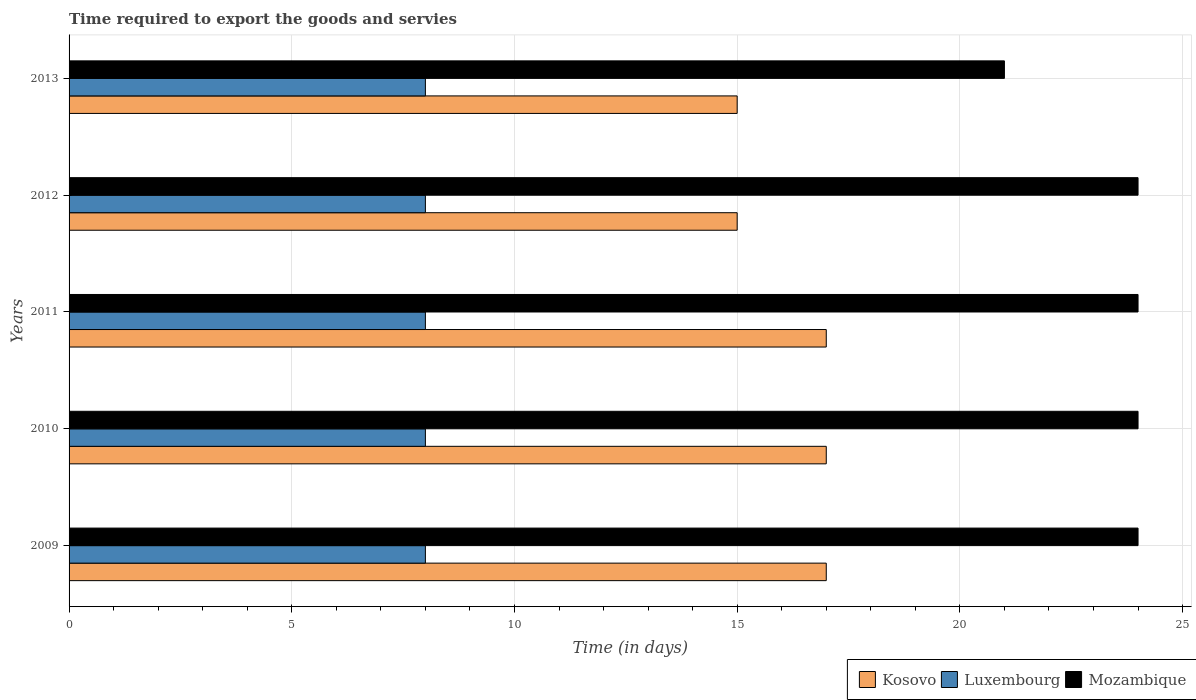How many different coloured bars are there?
Offer a very short reply. 3. How many groups of bars are there?
Give a very brief answer. 5. Are the number of bars per tick equal to the number of legend labels?
Give a very brief answer. Yes. Are the number of bars on each tick of the Y-axis equal?
Offer a very short reply. Yes. How many bars are there on the 4th tick from the bottom?
Give a very brief answer. 3. What is the label of the 5th group of bars from the top?
Offer a terse response. 2009. Across all years, what is the maximum number of days required to export the goods and services in Luxembourg?
Provide a short and direct response. 8. In which year was the number of days required to export the goods and services in Mozambique maximum?
Your answer should be compact. 2009. What is the total number of days required to export the goods and services in Mozambique in the graph?
Offer a terse response. 117. What is the difference between the number of days required to export the goods and services in Kosovo in 2011 and that in 2012?
Provide a short and direct response. 2. What is the difference between the number of days required to export the goods and services in Kosovo in 2011 and the number of days required to export the goods and services in Luxembourg in 2013?
Make the answer very short. 9. What is the average number of days required to export the goods and services in Mozambique per year?
Ensure brevity in your answer.  23.4. In how many years, is the number of days required to export the goods and services in Kosovo greater than 13 days?
Your answer should be very brief. 5. What is the ratio of the number of days required to export the goods and services in Luxembourg in 2009 to that in 2011?
Ensure brevity in your answer.  1. Is the number of days required to export the goods and services in Mozambique in 2012 less than that in 2013?
Give a very brief answer. No. In how many years, is the number of days required to export the goods and services in Kosovo greater than the average number of days required to export the goods and services in Kosovo taken over all years?
Your answer should be very brief. 3. What does the 1st bar from the top in 2010 represents?
Your response must be concise. Mozambique. What does the 3rd bar from the bottom in 2011 represents?
Your answer should be very brief. Mozambique. Is it the case that in every year, the sum of the number of days required to export the goods and services in Kosovo and number of days required to export the goods and services in Luxembourg is greater than the number of days required to export the goods and services in Mozambique?
Keep it short and to the point. No. How many bars are there?
Your response must be concise. 15. Are all the bars in the graph horizontal?
Your answer should be very brief. Yes. What is the difference between two consecutive major ticks on the X-axis?
Your answer should be very brief. 5. Does the graph contain any zero values?
Offer a very short reply. No. Where does the legend appear in the graph?
Your response must be concise. Bottom right. How many legend labels are there?
Give a very brief answer. 3. What is the title of the graph?
Give a very brief answer. Time required to export the goods and servies. Does "Poland" appear as one of the legend labels in the graph?
Keep it short and to the point. No. What is the label or title of the X-axis?
Keep it short and to the point. Time (in days). What is the label or title of the Y-axis?
Keep it short and to the point. Years. What is the Time (in days) of Kosovo in 2009?
Offer a very short reply. 17. What is the Time (in days) of Luxembourg in 2009?
Your answer should be compact. 8. What is the Time (in days) of Kosovo in 2010?
Provide a succinct answer. 17. What is the Time (in days) of Luxembourg in 2010?
Give a very brief answer. 8. What is the Time (in days) in Mozambique in 2010?
Your response must be concise. 24. What is the Time (in days) of Kosovo in 2011?
Offer a terse response. 17. What is the Time (in days) in Kosovo in 2012?
Your answer should be very brief. 15. What is the Time (in days) in Luxembourg in 2012?
Your response must be concise. 8. What is the Time (in days) in Mozambique in 2012?
Provide a succinct answer. 24. What is the Time (in days) of Mozambique in 2013?
Offer a terse response. 21. Across all years, what is the minimum Time (in days) of Kosovo?
Your answer should be very brief. 15. Across all years, what is the minimum Time (in days) in Luxembourg?
Your answer should be compact. 8. What is the total Time (in days) in Mozambique in the graph?
Provide a succinct answer. 117. What is the difference between the Time (in days) in Luxembourg in 2009 and that in 2010?
Offer a very short reply. 0. What is the difference between the Time (in days) in Mozambique in 2009 and that in 2010?
Provide a short and direct response. 0. What is the difference between the Time (in days) of Kosovo in 2009 and that in 2011?
Your response must be concise. 0. What is the difference between the Time (in days) in Mozambique in 2009 and that in 2011?
Provide a succinct answer. 0. What is the difference between the Time (in days) of Luxembourg in 2009 and that in 2012?
Make the answer very short. 0. What is the difference between the Time (in days) of Luxembourg in 2009 and that in 2013?
Give a very brief answer. 0. What is the difference between the Time (in days) of Luxembourg in 2010 and that in 2011?
Your answer should be compact. 0. What is the difference between the Time (in days) of Mozambique in 2010 and that in 2011?
Provide a short and direct response. 0. What is the difference between the Time (in days) of Mozambique in 2010 and that in 2012?
Offer a very short reply. 0. What is the difference between the Time (in days) in Kosovo in 2010 and that in 2013?
Your answer should be compact. 2. What is the difference between the Time (in days) of Kosovo in 2011 and that in 2012?
Offer a terse response. 2. What is the difference between the Time (in days) of Luxembourg in 2011 and that in 2013?
Your answer should be compact. 0. What is the difference between the Time (in days) of Luxembourg in 2012 and that in 2013?
Your answer should be very brief. 0. What is the difference between the Time (in days) of Mozambique in 2012 and that in 2013?
Provide a succinct answer. 3. What is the difference between the Time (in days) in Luxembourg in 2009 and the Time (in days) in Mozambique in 2010?
Keep it short and to the point. -16. What is the difference between the Time (in days) in Kosovo in 2009 and the Time (in days) in Luxembourg in 2011?
Offer a terse response. 9. What is the difference between the Time (in days) of Kosovo in 2009 and the Time (in days) of Luxembourg in 2012?
Offer a very short reply. 9. What is the difference between the Time (in days) in Luxembourg in 2009 and the Time (in days) in Mozambique in 2012?
Keep it short and to the point. -16. What is the difference between the Time (in days) of Kosovo in 2009 and the Time (in days) of Mozambique in 2013?
Provide a succinct answer. -4. What is the difference between the Time (in days) in Kosovo in 2010 and the Time (in days) in Mozambique in 2011?
Your answer should be compact. -7. What is the difference between the Time (in days) of Luxembourg in 2010 and the Time (in days) of Mozambique in 2011?
Your answer should be very brief. -16. What is the difference between the Time (in days) of Kosovo in 2010 and the Time (in days) of Luxembourg in 2012?
Make the answer very short. 9. What is the difference between the Time (in days) of Kosovo in 2010 and the Time (in days) of Mozambique in 2012?
Provide a short and direct response. -7. What is the difference between the Time (in days) of Kosovo in 2010 and the Time (in days) of Mozambique in 2013?
Your response must be concise. -4. What is the difference between the Time (in days) in Luxembourg in 2010 and the Time (in days) in Mozambique in 2013?
Give a very brief answer. -13. What is the difference between the Time (in days) of Kosovo in 2011 and the Time (in days) of Mozambique in 2012?
Your answer should be very brief. -7. What is the difference between the Time (in days) of Luxembourg in 2011 and the Time (in days) of Mozambique in 2013?
Provide a succinct answer. -13. What is the difference between the Time (in days) in Kosovo in 2012 and the Time (in days) in Mozambique in 2013?
Provide a succinct answer. -6. What is the average Time (in days) of Mozambique per year?
Your answer should be compact. 23.4. In the year 2009, what is the difference between the Time (in days) in Kosovo and Time (in days) in Mozambique?
Keep it short and to the point. -7. In the year 2010, what is the difference between the Time (in days) of Kosovo and Time (in days) of Mozambique?
Offer a terse response. -7. In the year 2010, what is the difference between the Time (in days) in Luxembourg and Time (in days) in Mozambique?
Keep it short and to the point. -16. In the year 2011, what is the difference between the Time (in days) in Kosovo and Time (in days) in Mozambique?
Provide a succinct answer. -7. In the year 2011, what is the difference between the Time (in days) of Luxembourg and Time (in days) of Mozambique?
Offer a terse response. -16. In the year 2012, what is the difference between the Time (in days) of Kosovo and Time (in days) of Luxembourg?
Give a very brief answer. 7. In the year 2013, what is the difference between the Time (in days) in Kosovo and Time (in days) in Mozambique?
Provide a short and direct response. -6. In the year 2013, what is the difference between the Time (in days) of Luxembourg and Time (in days) of Mozambique?
Offer a terse response. -13. What is the ratio of the Time (in days) in Kosovo in 2009 to that in 2010?
Your answer should be very brief. 1. What is the ratio of the Time (in days) in Mozambique in 2009 to that in 2010?
Keep it short and to the point. 1. What is the ratio of the Time (in days) in Kosovo in 2009 to that in 2011?
Your answer should be very brief. 1. What is the ratio of the Time (in days) of Luxembourg in 2009 to that in 2011?
Provide a succinct answer. 1. What is the ratio of the Time (in days) in Kosovo in 2009 to that in 2012?
Your response must be concise. 1.13. What is the ratio of the Time (in days) in Luxembourg in 2009 to that in 2012?
Offer a very short reply. 1. What is the ratio of the Time (in days) of Mozambique in 2009 to that in 2012?
Ensure brevity in your answer.  1. What is the ratio of the Time (in days) in Kosovo in 2009 to that in 2013?
Your answer should be compact. 1.13. What is the ratio of the Time (in days) in Kosovo in 2010 to that in 2011?
Offer a terse response. 1. What is the ratio of the Time (in days) of Luxembourg in 2010 to that in 2011?
Provide a succinct answer. 1. What is the ratio of the Time (in days) in Mozambique in 2010 to that in 2011?
Your answer should be very brief. 1. What is the ratio of the Time (in days) of Kosovo in 2010 to that in 2012?
Provide a short and direct response. 1.13. What is the ratio of the Time (in days) of Luxembourg in 2010 to that in 2012?
Make the answer very short. 1. What is the ratio of the Time (in days) in Kosovo in 2010 to that in 2013?
Keep it short and to the point. 1.13. What is the ratio of the Time (in days) of Kosovo in 2011 to that in 2012?
Give a very brief answer. 1.13. What is the ratio of the Time (in days) of Luxembourg in 2011 to that in 2012?
Offer a terse response. 1. What is the ratio of the Time (in days) of Mozambique in 2011 to that in 2012?
Offer a terse response. 1. What is the ratio of the Time (in days) of Kosovo in 2011 to that in 2013?
Offer a terse response. 1.13. What is the ratio of the Time (in days) of Luxembourg in 2011 to that in 2013?
Provide a succinct answer. 1. What is the ratio of the Time (in days) in Kosovo in 2012 to that in 2013?
Offer a terse response. 1. What is the difference between the highest and the second highest Time (in days) of Mozambique?
Provide a succinct answer. 0. What is the difference between the highest and the lowest Time (in days) in Mozambique?
Make the answer very short. 3. 